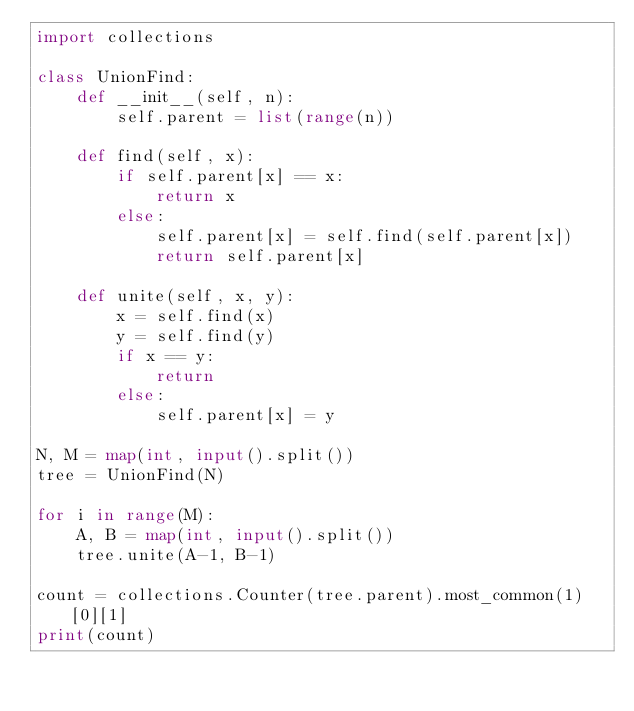Convert code to text. <code><loc_0><loc_0><loc_500><loc_500><_Python_>import collections

class UnionFind:
    def __init__(self, n):
        self.parent = list(range(n))

    def find(self, x):
        if self.parent[x] == x:
            return x
        else:
            self.parent[x] = self.find(self.parent[x])
            return self.parent[x]

    def unite(self, x, y):
        x = self.find(x)
        y = self.find(y)
        if x == y:
            return
        else:
            self.parent[x] = y

N, M = map(int, input().split())
tree = UnionFind(N)

for i in range(M):
    A, B = map(int, input().split())
    tree.unite(A-1, B-1)

count = collections.Counter(tree.parent).most_common(1)[0][1]
print(count)
</code> 